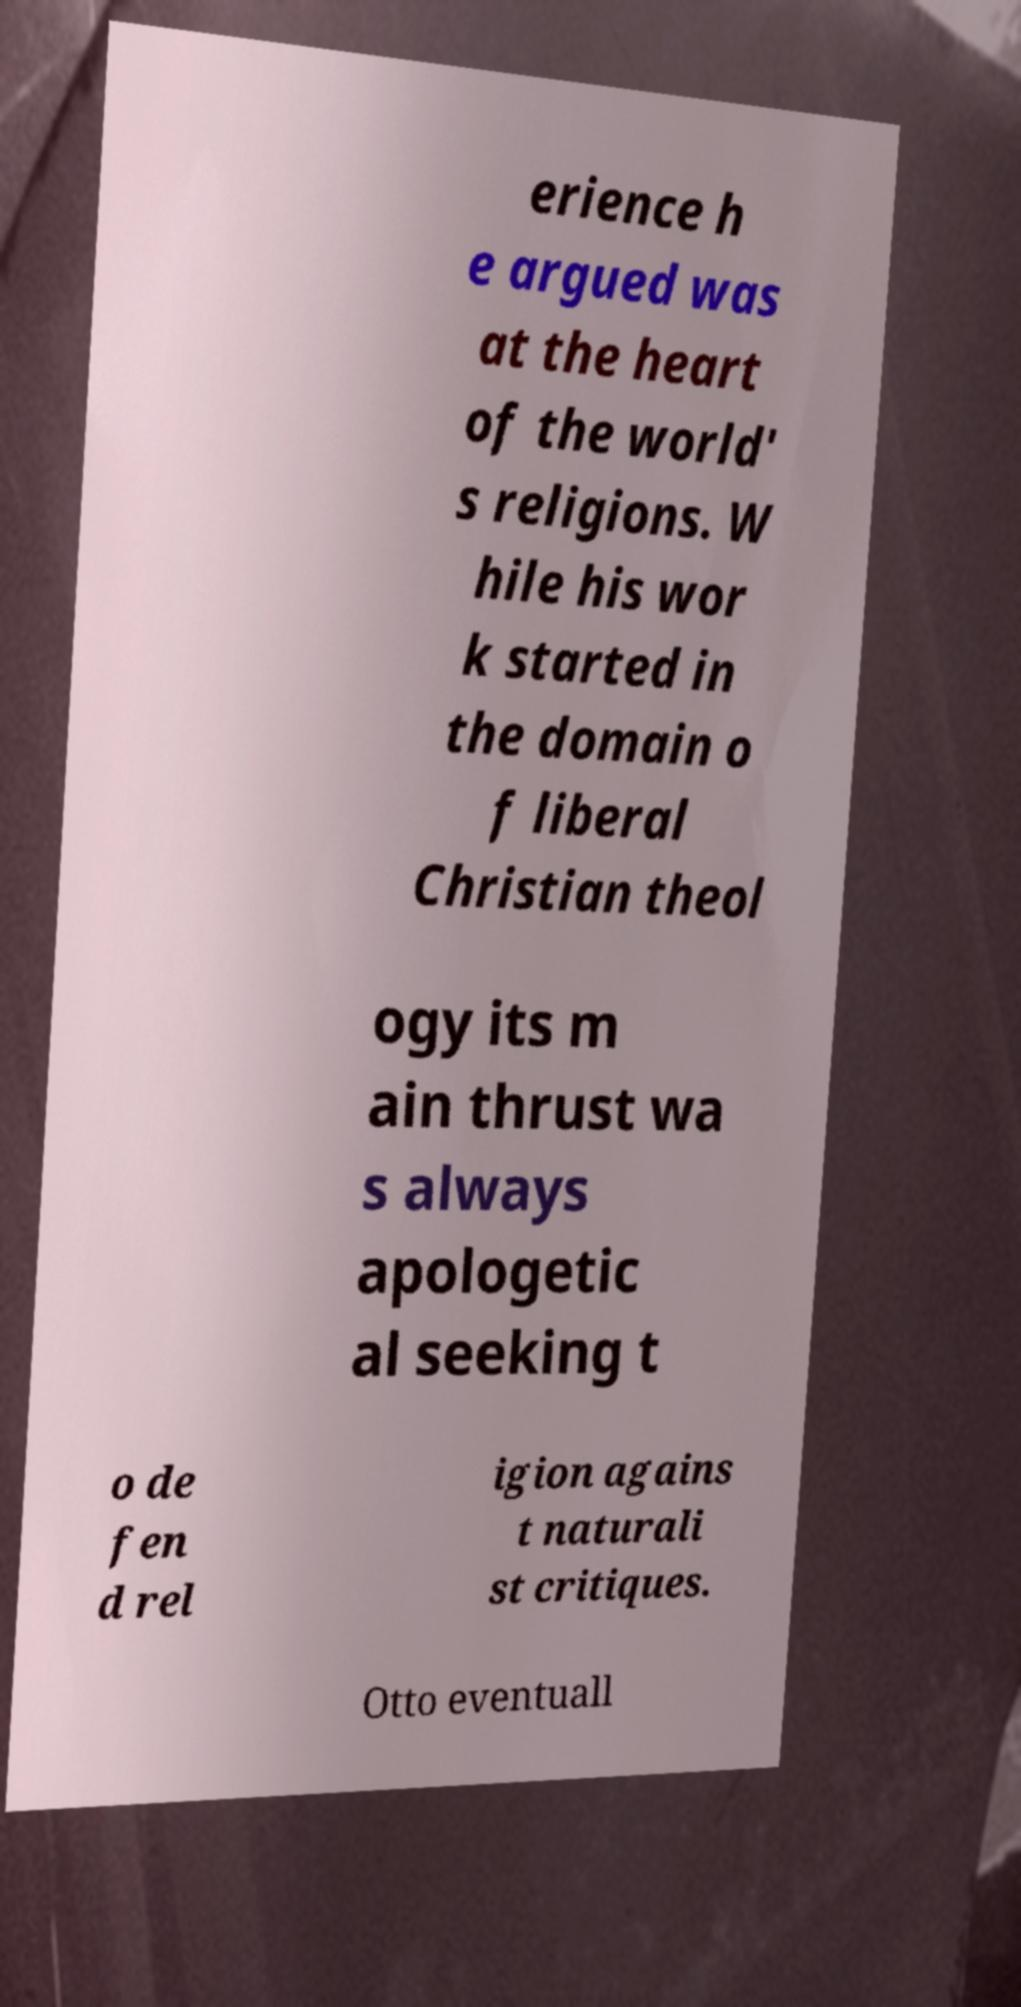Can you read and provide the text displayed in the image?This photo seems to have some interesting text. Can you extract and type it out for me? erience h e argued was at the heart of the world' s religions. W hile his wor k started in the domain o f liberal Christian theol ogy its m ain thrust wa s always apologetic al seeking t o de fen d rel igion agains t naturali st critiques. Otto eventuall 